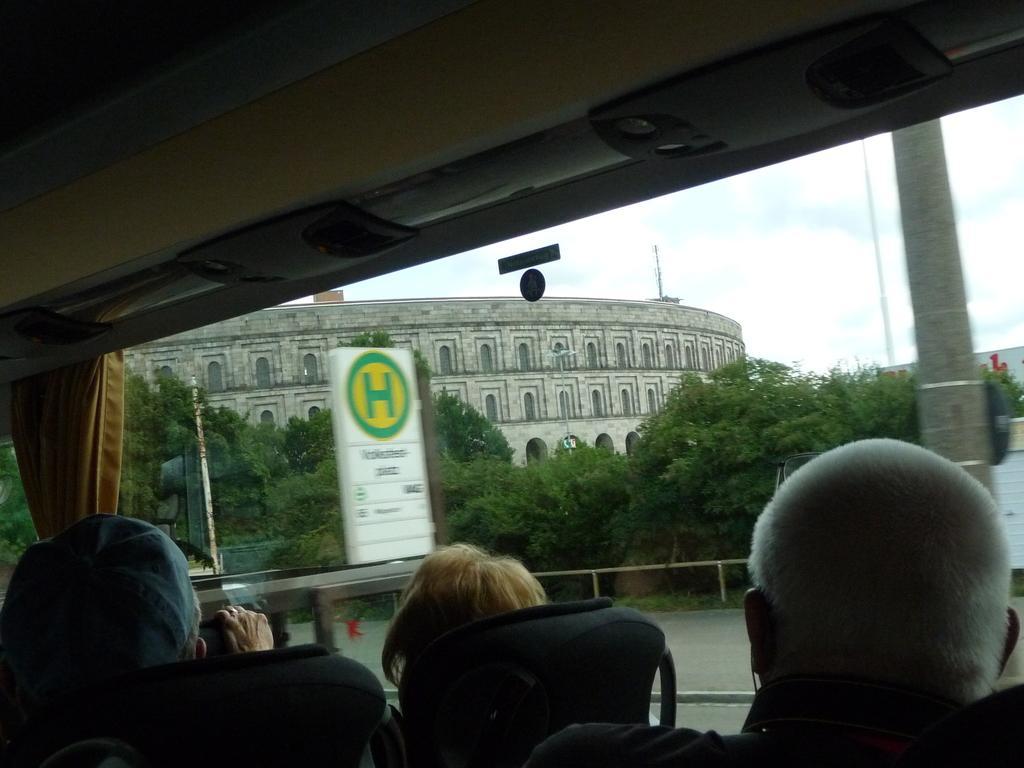Can you describe this image briefly? In the foreground I can see three persons are sitting on the chairs. In the background I can see trees, board, traffic poles, buildings and the sky. At the top I can see a rooftop. This image is taken may be in a day. 